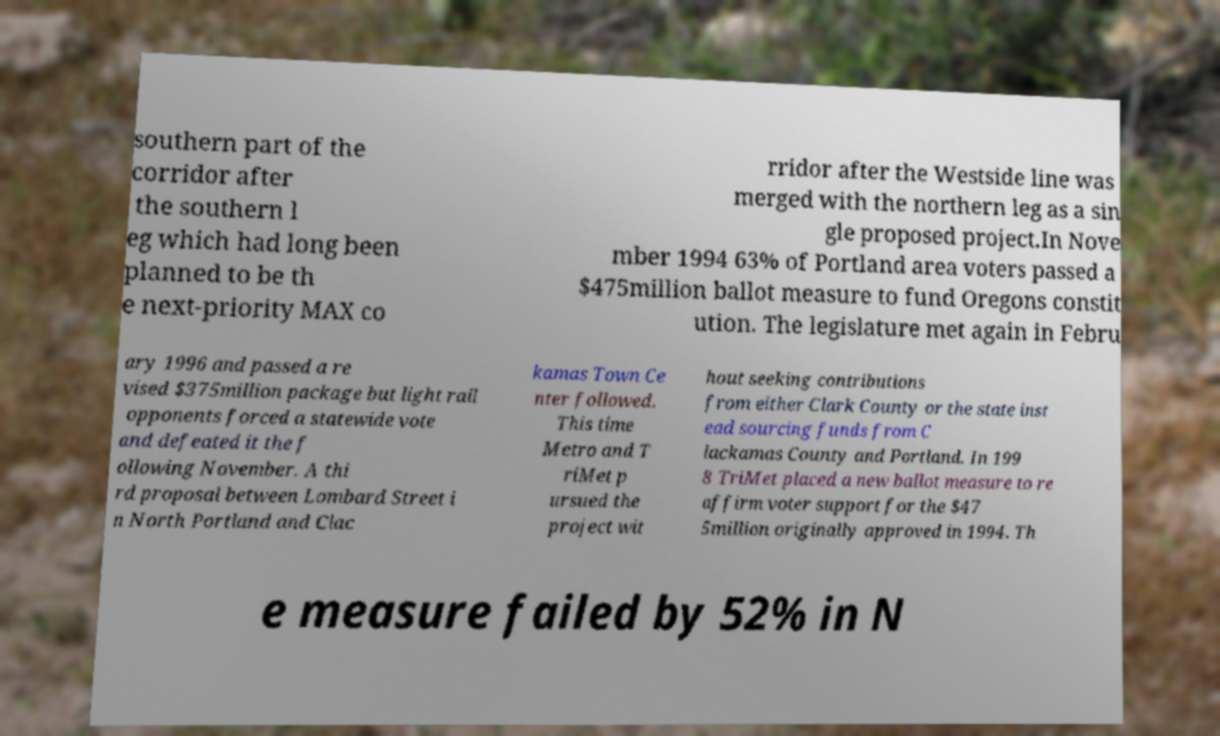There's text embedded in this image that I need extracted. Can you transcribe it verbatim? southern part of the corridor after the southern l eg which had long been planned to be th e next-priority MAX co rridor after the Westside line was merged with the northern leg as a sin gle proposed project.In Nove mber 1994 63% of Portland area voters passed a $475million ballot measure to fund Oregons constit ution. The legislature met again in Febru ary 1996 and passed a re vised $375million package but light rail opponents forced a statewide vote and defeated it the f ollowing November. A thi rd proposal between Lombard Street i n North Portland and Clac kamas Town Ce nter followed. This time Metro and T riMet p ursued the project wit hout seeking contributions from either Clark County or the state inst ead sourcing funds from C lackamas County and Portland. In 199 8 TriMet placed a new ballot measure to re affirm voter support for the $47 5million originally approved in 1994. Th e measure failed by 52% in N 